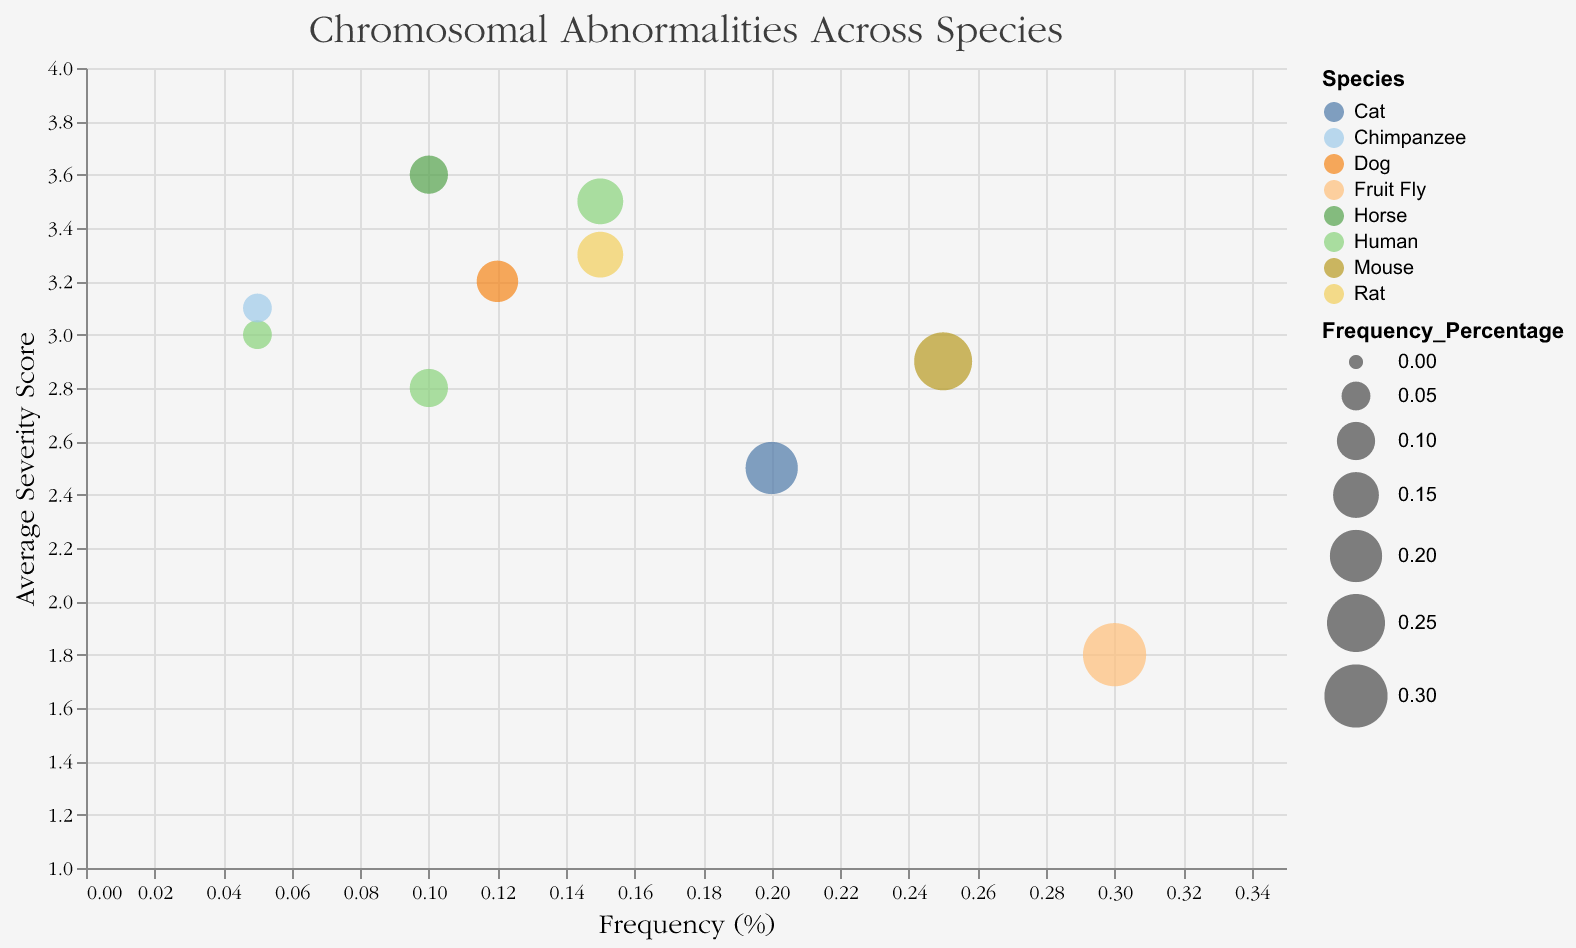What is the title of the chart? The title is located at the top of the chart and it stands out visually from the rest of the content due to its larger font size and distinct font style.
Answer: Chromosomal Abnormalities Across Species What is the x-axis representing? The x-axis represents the "Frequency (%)" of chromosomal abnormalities in different species. This can be inferred from the label on the axis and the distribution of data points.
Answer: Frequency (%) Which species has the highest frequency of chromosomal abnormalities? By observing the data points and their positions along the x-axis, the species with the point farthest to the right has the highest frequency.
Answer: Fruit Fly Which two species have the same frequency of chromosomal abnormalities at 0.1%? By locating the points along the x-axis with the same Frequency (%) of 0.1% and checking their corresponding species in the tooltip, we find that there are two species with this value.
Answer: Human and Horse Which chromosomal abnormality has the lowest average severity score? The chromosomal abnormality with the point located lowest on the y-axis represents the lowest average severity score. Hovering over this point reveals more details via the tooltip.
Answer: Trisomy 4 in Fruit Fly Compare the severity scores of the chromosomal abnormalities in Humans and Rats. Which is higher? By hovering over the points for Human and Rat, we can see the respective average severity scores and compare them.
Answer: Rat has a higher severity score What is the average severity score of Equine Monosomy X and Canine Xautosomal Aneuploidy? We sum the average severity scores of Equine Monosomy X (3.6) and Canine Xautosomal Aneuploidy (3.2) and then divide by 2 to get the average.
Answer: (3.6 + 3.2) / 2 = 3.4 Which species and chromosomal abnormality combination has both high frequency and high severity score? We need to look for a point that is far to the right on the x-axis (high frequency) and high on the y-axis (high severity score). The tooltip reveals the species and chromosomal abnormality.
Answer: Horse with Equine Monosomy X How does the severity score of Down Syndrome in Humans compare to the Monosomy 18 in Rats? By comparing the positions on the y-axis or looking at the tooltip details, we can infer their respective severity scores.
Answer: Down Syndrome in Humans has a similar severity score compared to Monosomy 18 in Rats What is the size of the bubble for Trisomy 19 in Mice relative to other data points? The size of the bubble can be visually compared with others; bubbles with larger sizes indicate higher frequency percentages. Trisomy 19 in Mice has one of the larger bubble sizes, indicating a relatively higher frequency percentage.
Answer: Relatively larger 